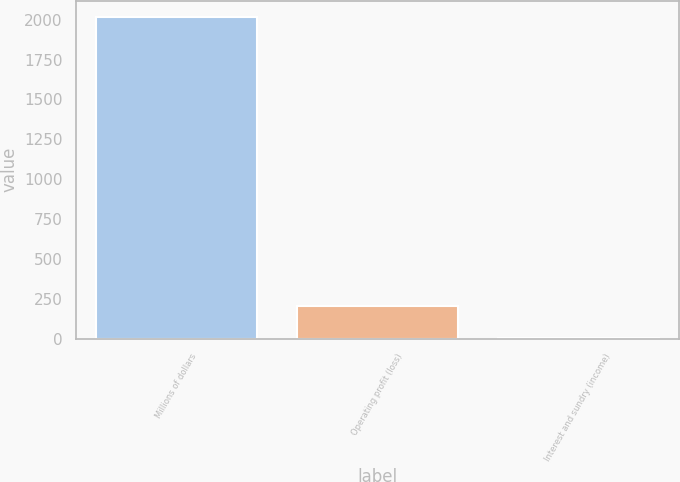Convert chart. <chart><loc_0><loc_0><loc_500><loc_500><bar_chart><fcel>Millions of dollars<fcel>Operating profit (loss)<fcel>Interest and sundry (income)<nl><fcel>2018<fcel>202.7<fcel>1<nl></chart> 